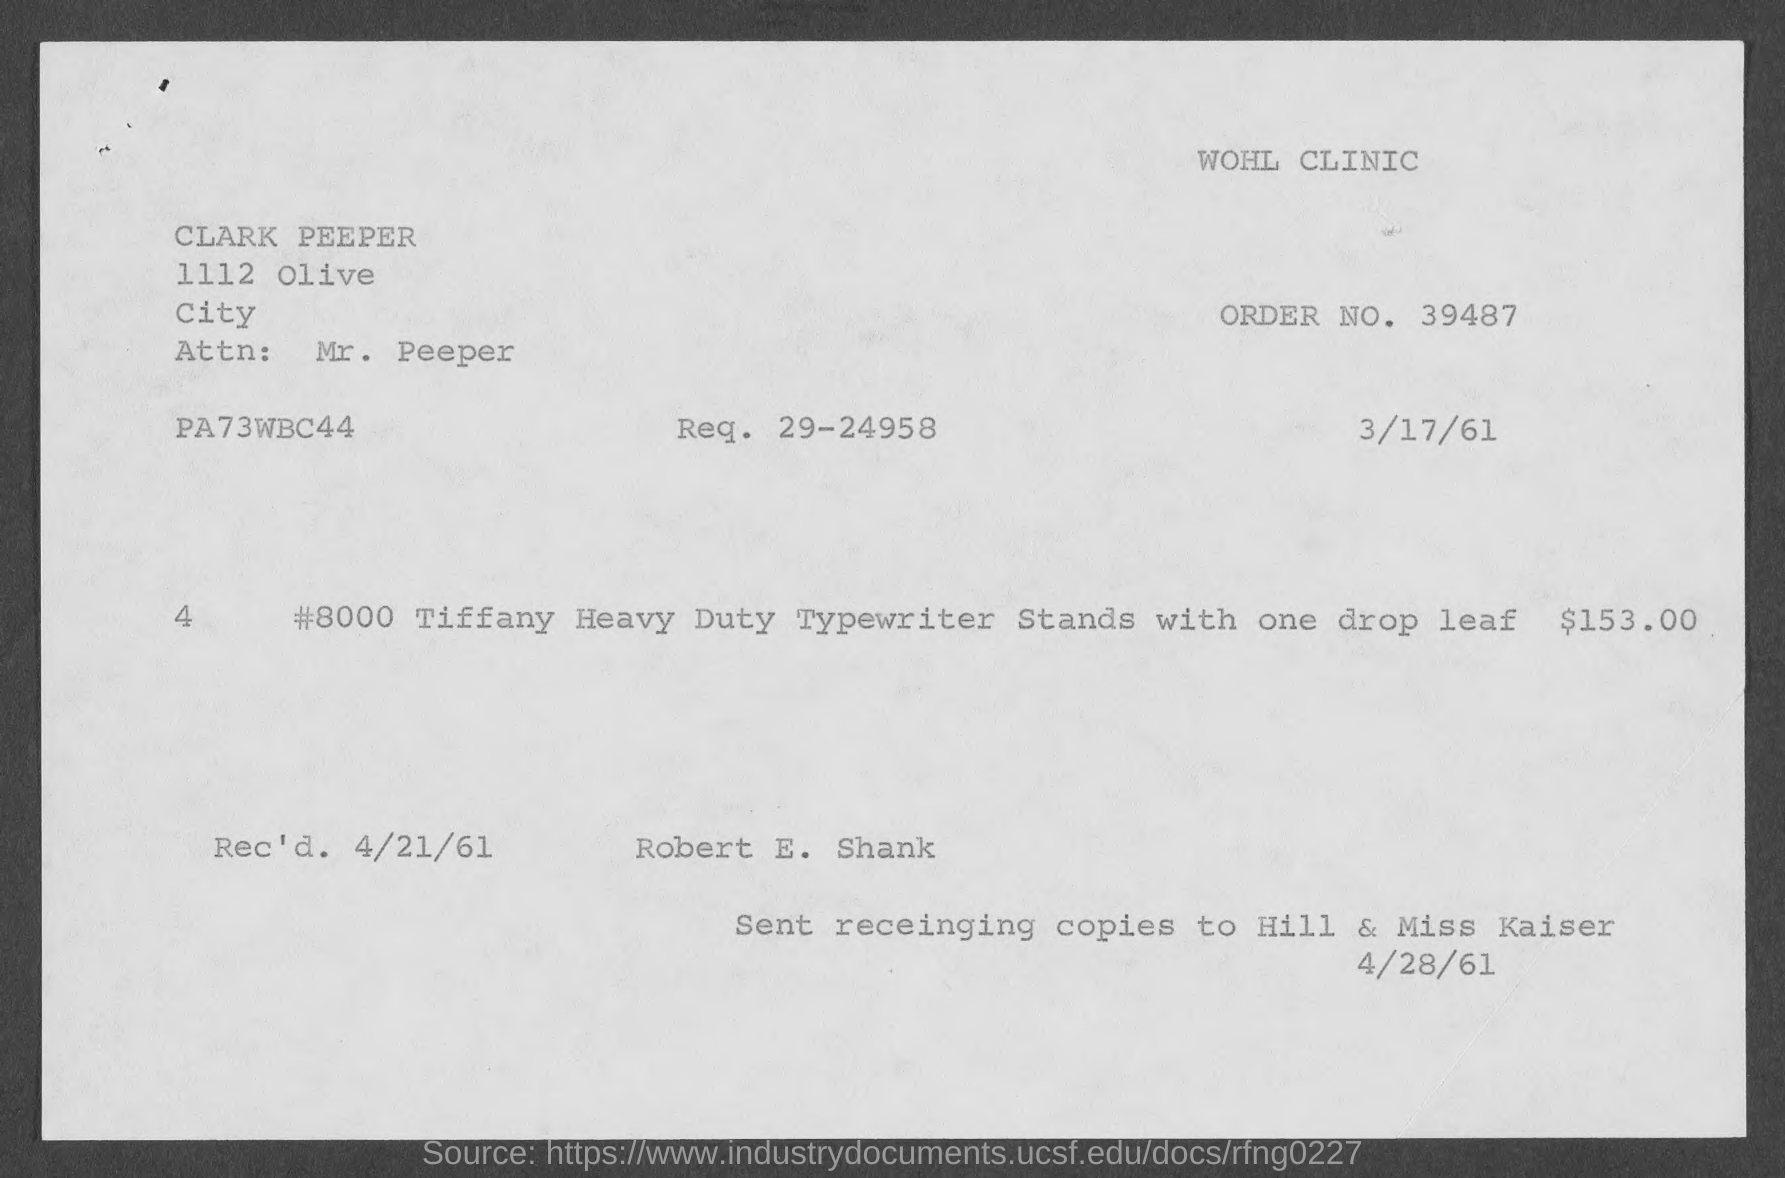Point out several critical features in this image. The request number mentioned in the given page is 29-24958. The name of the attention-worthy attn: mentioned in the given page is Mr. Peeper. The order number mentioned on the given page is 39487. The amount mentioned in the given form is $153.00. The received date mentioned in the given text is April 21, 1961. 